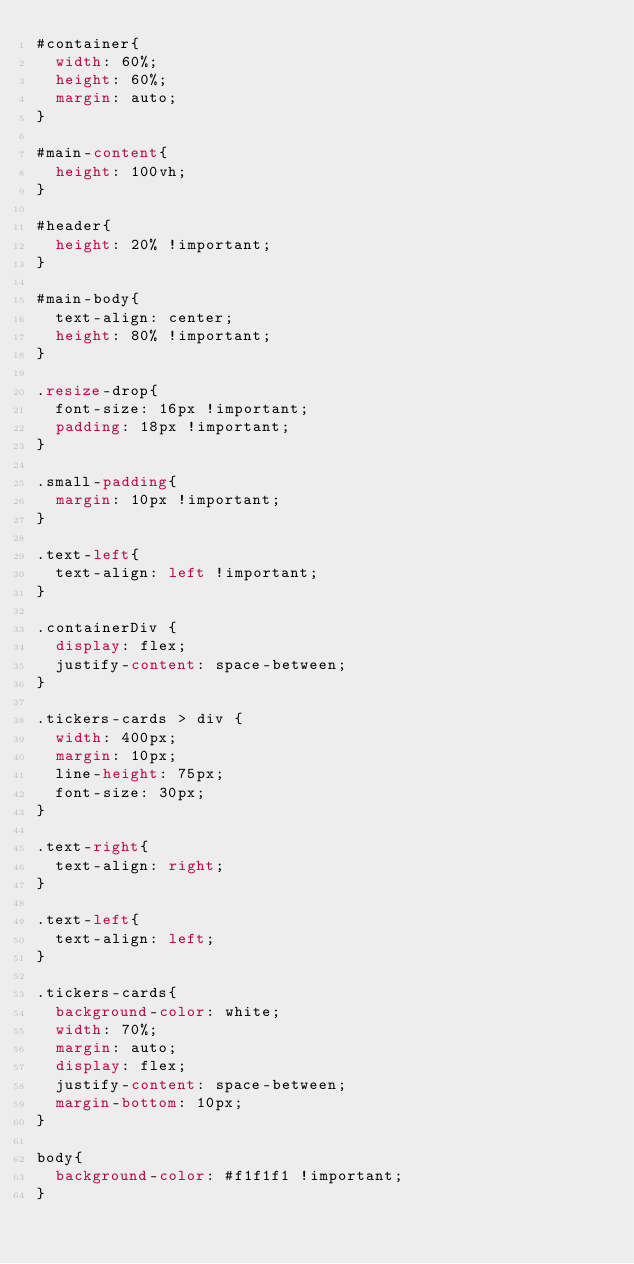Convert code to text. <code><loc_0><loc_0><loc_500><loc_500><_CSS_>#container{
  width: 60%;
  height: 60%;
  margin: auto;
}

#main-content{
  height: 100vh;
}

#header{
  height: 20% !important;
}

#main-body{
  text-align: center;
  height: 80% !important;
}

.resize-drop{
  font-size: 16px !important;
  padding: 18px !important;
}

.small-padding{
  margin: 10px !important;
}

.text-left{
  text-align: left !important;
}

.containerDiv {
  display: flex;
  justify-content: space-between;
}

.tickers-cards > div {
  width: 400px;
  margin: 10px;
  line-height: 75px;
  font-size: 30px;
}

.text-right{
  text-align: right;
}

.text-left{
  text-align: left;
}

.tickers-cards{
  background-color: white;
  width: 70%;
  margin: auto;
  display: flex;
  justify-content: space-between;
  margin-bottom: 10px;
}

body{
  background-color: #f1f1f1 !important;
}</code> 